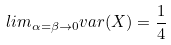Convert formula to latex. <formula><loc_0><loc_0><loc_500><loc_500>l i m _ { \alpha = \beta \rightarrow 0 } v a r ( X ) = \frac { 1 } { 4 }</formula> 